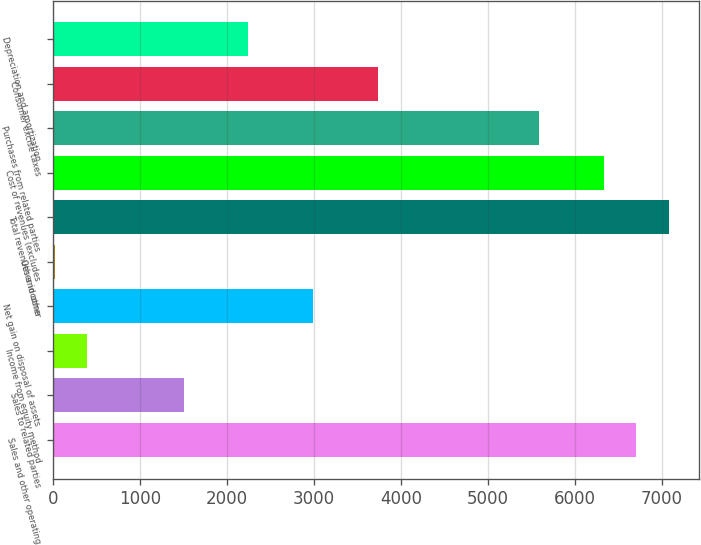Convert chart. <chart><loc_0><loc_0><loc_500><loc_500><bar_chart><fcel>Sales and other operating<fcel>Sales to related parties<fcel>Income from equity method<fcel>Net gain on disposal of assets<fcel>Other income<fcel>Total revenues and other<fcel>Cost of revenues (excludes<fcel>Purchases from related parties<fcel>Consumer excise taxes<fcel>Depreciation and amortization<nl><fcel>6709<fcel>1501<fcel>385<fcel>2989<fcel>13<fcel>7081<fcel>6337<fcel>5593<fcel>3733<fcel>2245<nl></chart> 